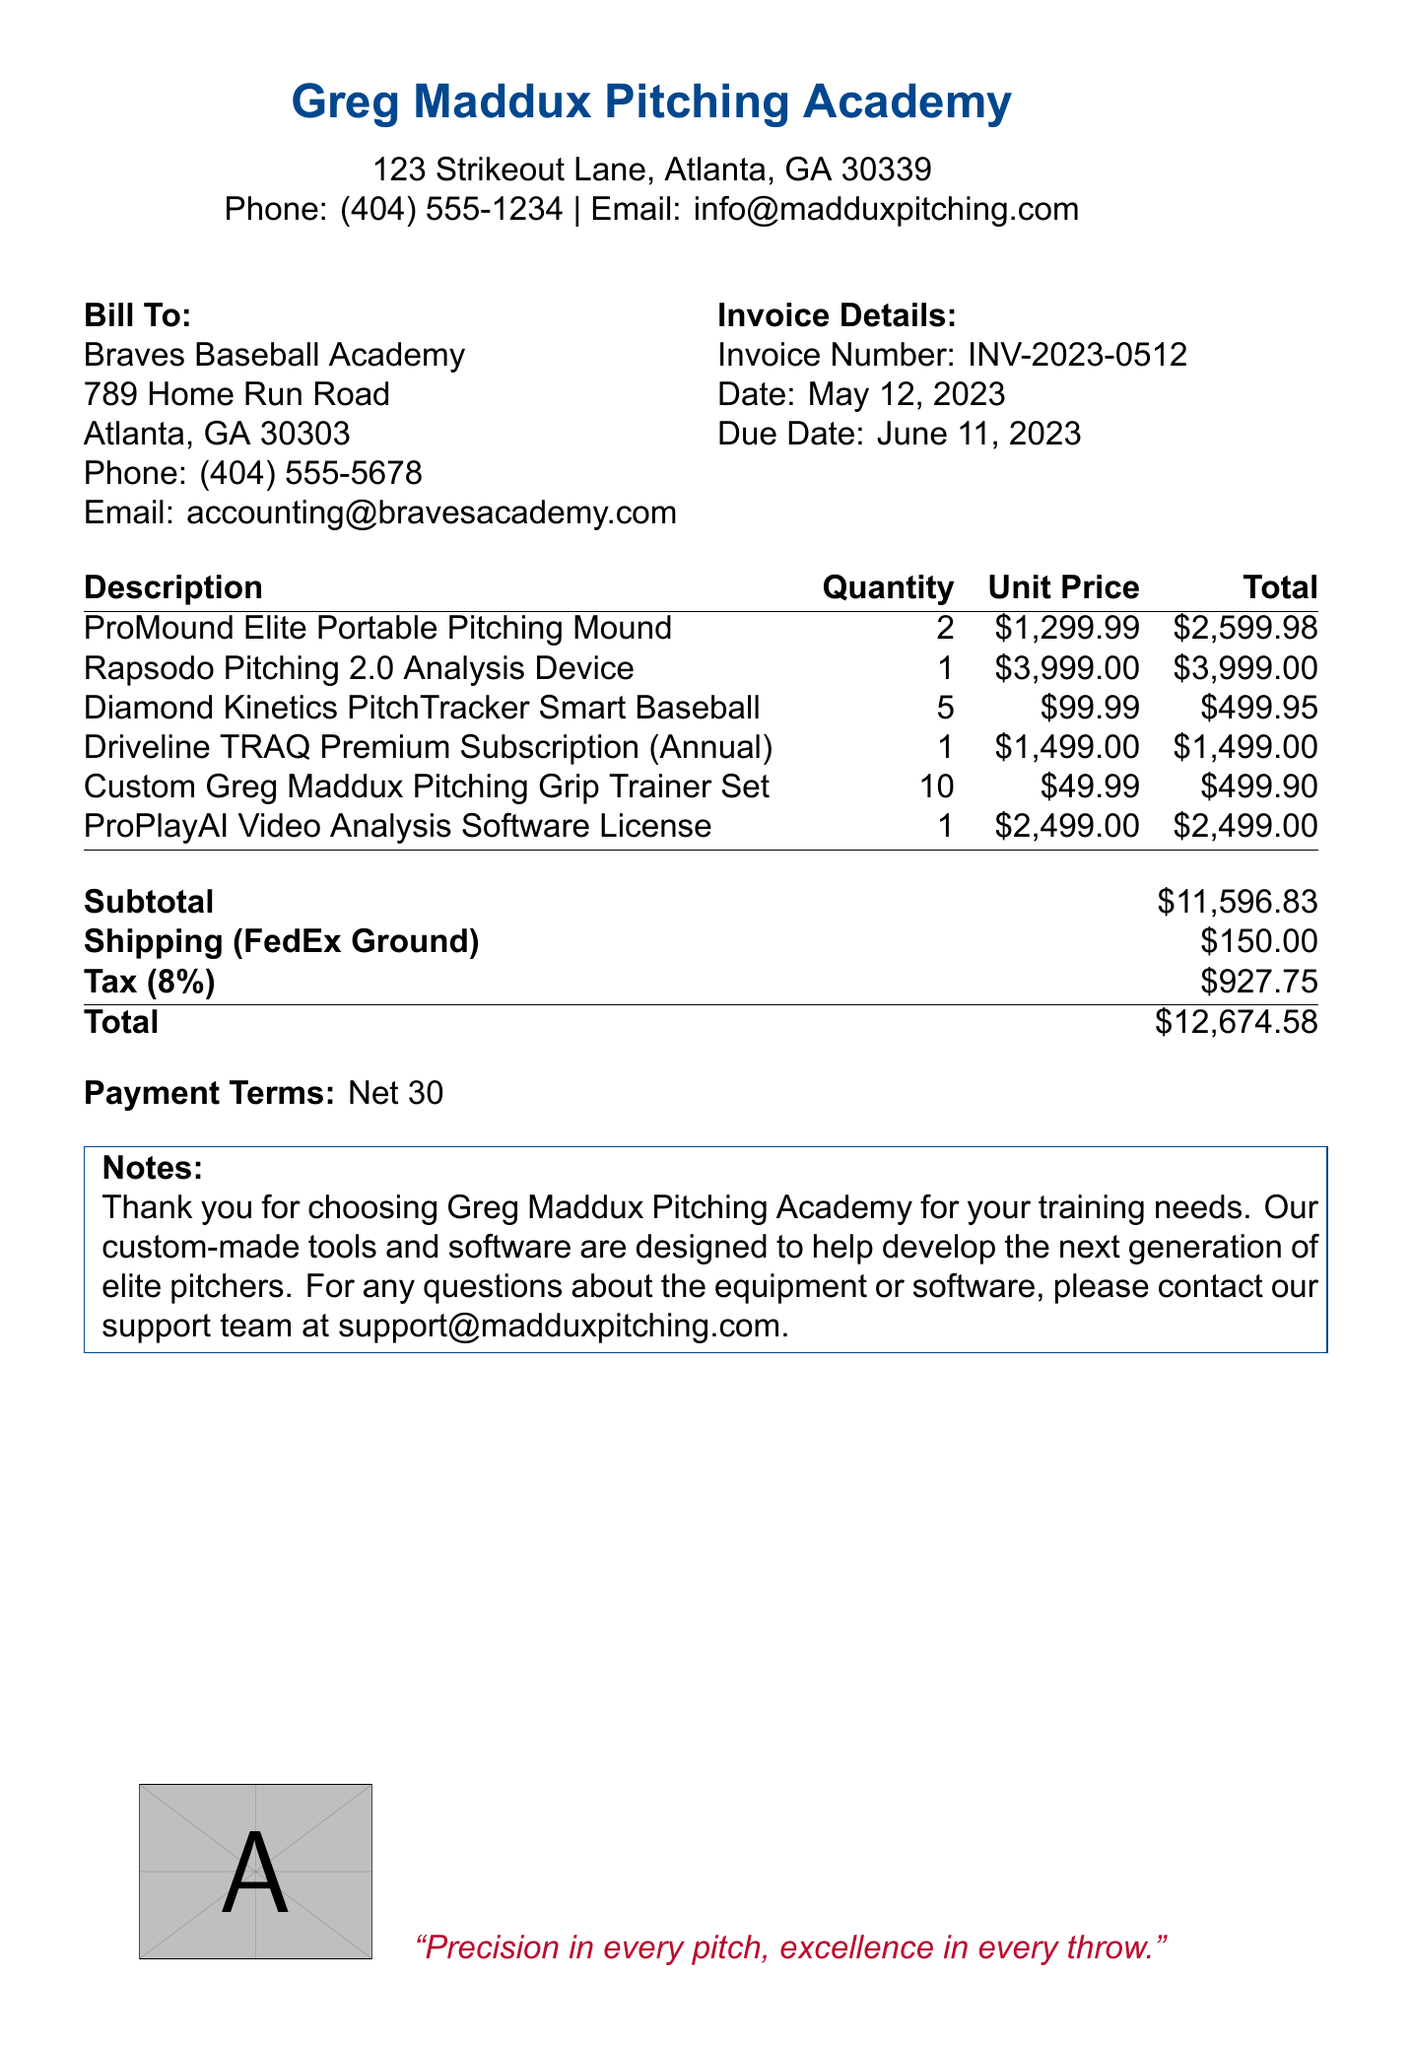What is the invoice number? The invoice number is a unique identifier for the billing document, found in the invoice details section.
Answer: INV-2023-0512 What is the due date for payment? The due date indicates when the payment is expected and is also included in the invoice details.
Answer: June 11, 2023 Who is the biller? The biller is the entity sending the invoice, found at the top of the document.
Answer: Greg Maddux Pitching Academy What is the total amount due? The total amount due is the sum of the subtotal, shipping, and tax, clearly stated in the total section.
Answer: $12,674.58 How many Diamond Kinetics PitchTracker Smart Baseballs were purchased? The quantity of each item is listed in the invoice, indicating how many were bought.
Answer: 5 What is the shipping method listed? The shipping method specifies how the items will be delivered, stated in the shipping section.
Answer: FedEx Ground What is the tax rate applied to the invoice? The tax rate is the percentage applied to the subtotal for calculating tax, provided in the totals section.
Answer: 8% How much does the ProMound Elite Portable Pitching Mound cost per unit? The unit price is given for each item in the invoice for clarity on individual costs.
Answer: $1,299.99 What payment terms are specified in the document? Payment terms detail how long the recipient has to settle the invoice, found in the invoice body.
Answer: Net 30 